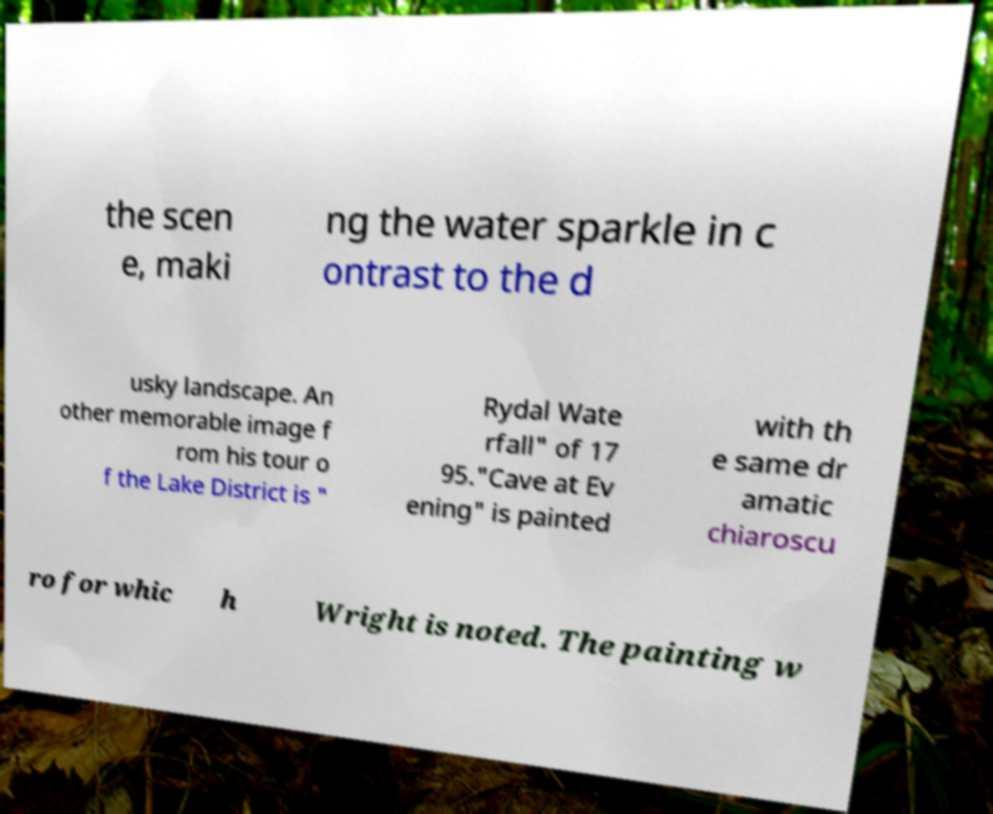Please read and relay the text visible in this image. What does it say? the scen e, maki ng the water sparkle in c ontrast to the d usky landscape. An other memorable image f rom his tour o f the Lake District is " Rydal Wate rfall" of 17 95."Cave at Ev ening" is painted with th e same dr amatic chiaroscu ro for whic h Wright is noted. The painting w 